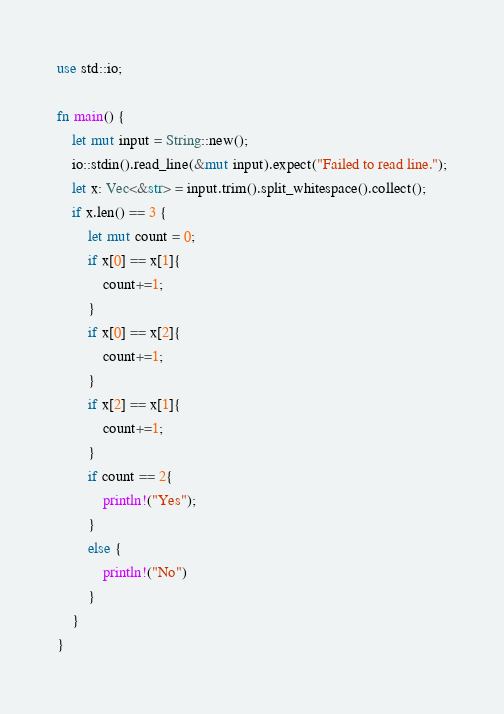Convert code to text. <code><loc_0><loc_0><loc_500><loc_500><_Rust_>use std::io;

fn main() {
    let mut input = String::new();
    io::stdin().read_line(&mut input).expect("Failed to read line.");
    let x: Vec<&str> = input.trim().split_whitespace().collect();
    if x.len() == 3 {
        let mut count = 0;
        if x[0] == x[1]{
            count+=1;
        }
        if x[0] == x[2]{
            count+=1;
        }
        if x[2] == x[1]{
            count+=1;
        }
        if count == 2{
            println!("Yes");
        }
        else {
            println!("No")
        }
    }
}</code> 